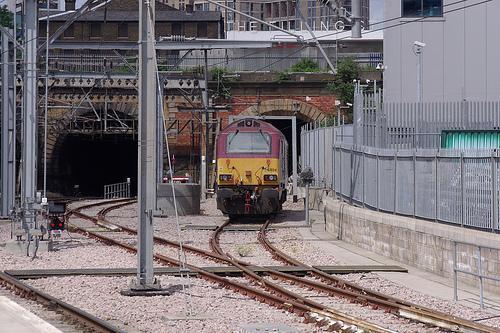How many trains are shown?
Give a very brief answer. 1. 